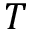Convert formula to latex. <formula><loc_0><loc_0><loc_500><loc_500>T</formula> 